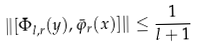<formula> <loc_0><loc_0><loc_500><loc_500>\| [ \bar { \Phi } _ { l , r } ( y ) , \bar { \varphi } _ { r } ( x ) ] \| \leq \frac { 1 } { l + 1 }</formula> 